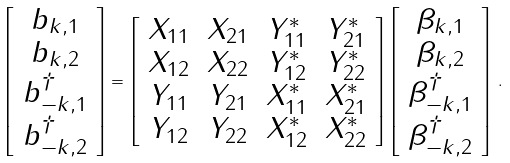<formula> <loc_0><loc_0><loc_500><loc_500>\left [ \begin{array} { c } { { b _ { { k } , 1 } } } \\ { { b _ { { k } , 2 } } } \\ { { b _ { - { k } , 1 } ^ { \dag } } } \\ { { b _ { - { k } , 2 } ^ { \dag } } } \end{array} \right ] = \left [ \begin{array} { c c c c } { { X _ { 1 1 } } } & { { X _ { 2 1 } } } & { { Y _ { 1 1 } ^ { * } } } & { { Y _ { 2 1 } ^ { * } } } \\ { { X _ { 1 2 } } } & { { X _ { 2 2 } } } & { { Y _ { 1 2 } ^ { * } } } & { { Y _ { 2 2 } ^ { * } } } \\ { { Y _ { 1 1 } } } & { { Y _ { 2 1 } } } & { { X _ { 1 1 } ^ { * } } } & { { X _ { 2 1 } ^ { * } } } \\ { { Y _ { 1 2 } } } & { { Y _ { 2 2 } } } & { { X _ { 1 2 } ^ { * } } } & { { X _ { 2 2 } ^ { * } } } \end{array} \right ] \left [ \begin{array} { c } { { \beta _ { { k } , 1 } } } \\ { { \beta _ { { k } , 2 } } } \\ { { \beta _ { - { k } , 1 } ^ { \dag } } } \\ { { \beta _ { - { k } , 2 } ^ { \dag } } } \end{array} \right ] \, .</formula> 